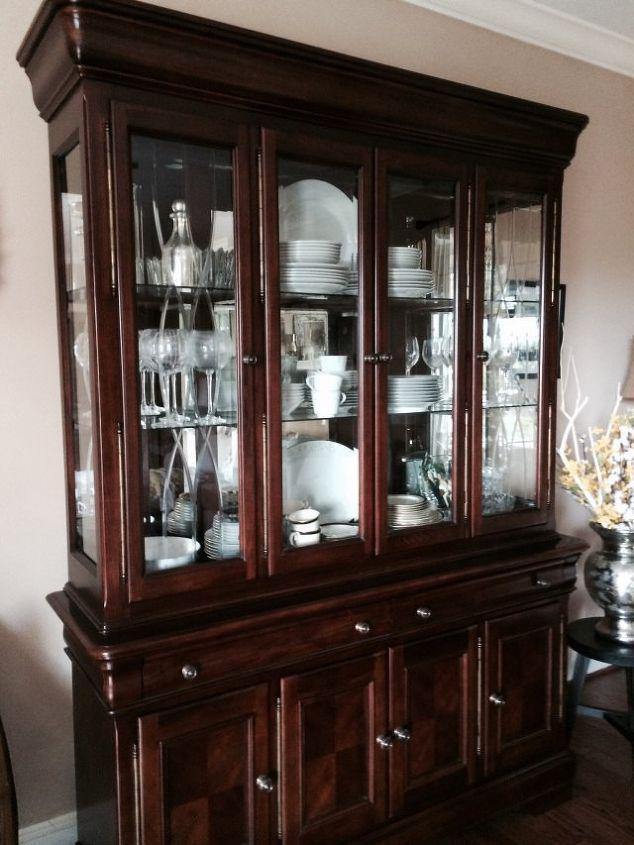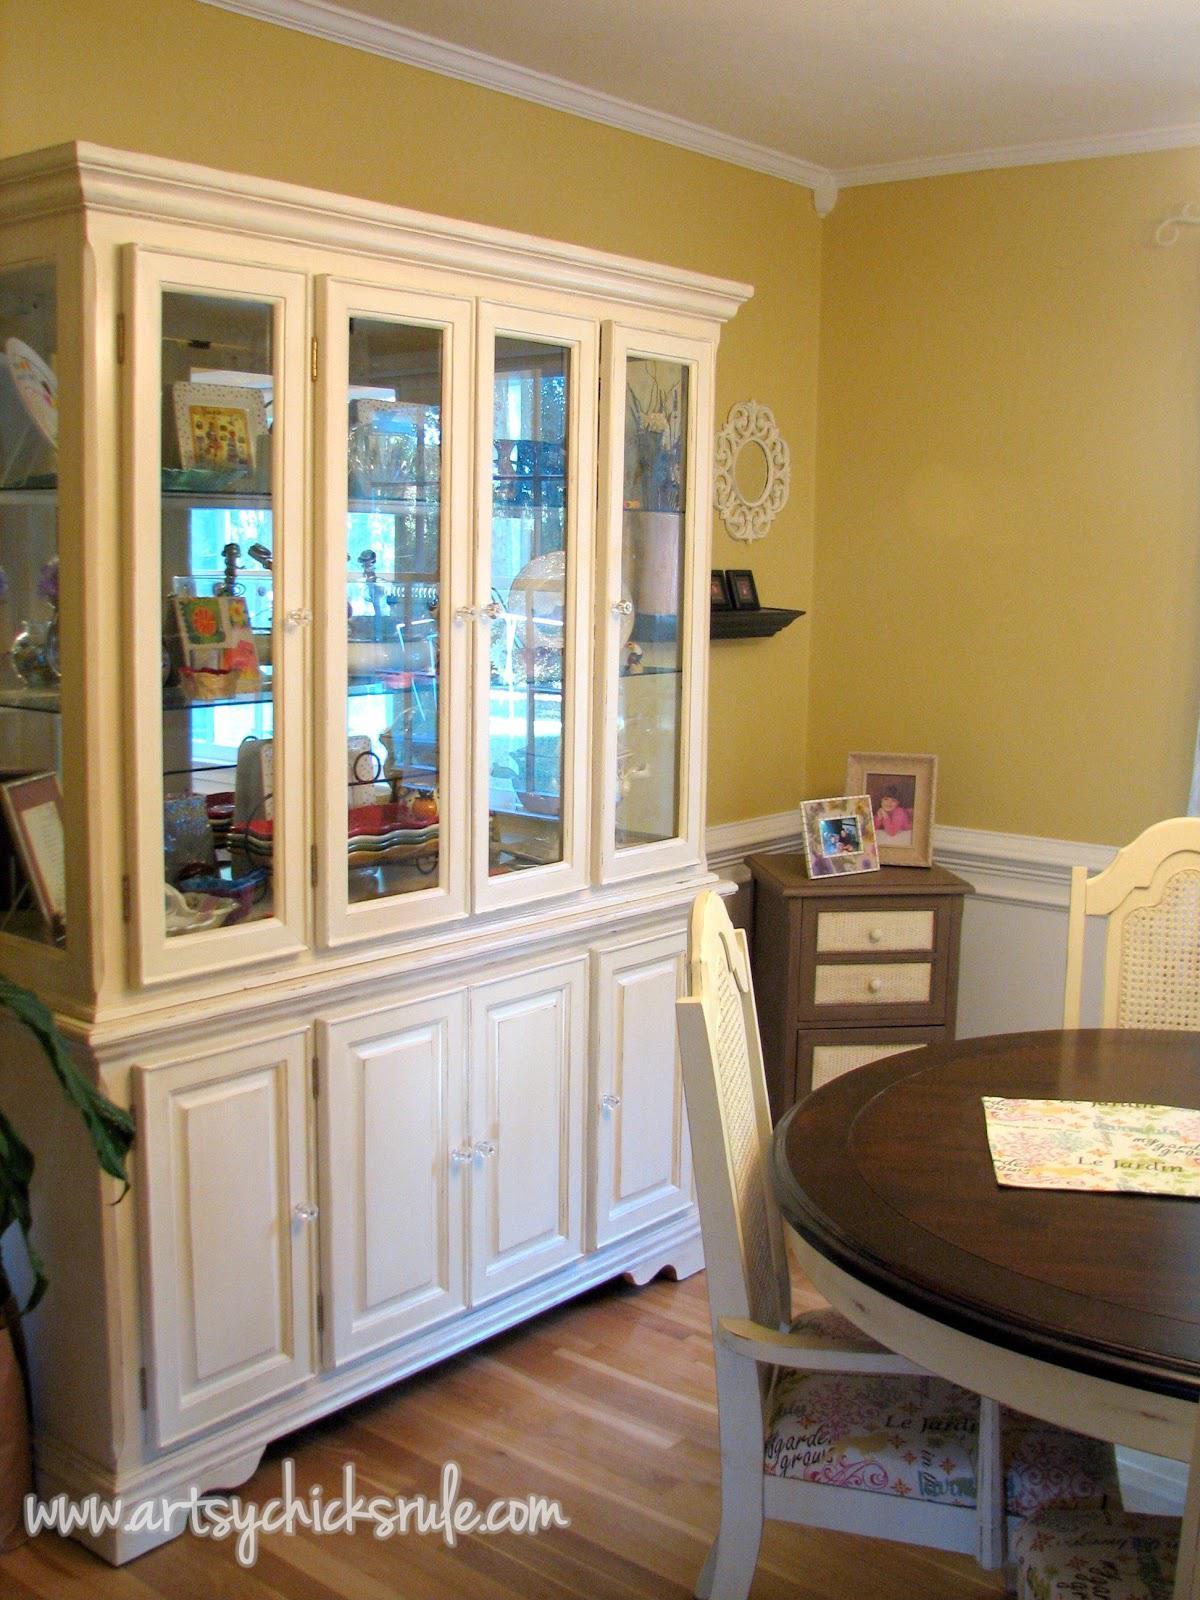The first image is the image on the left, the second image is the image on the right. Analyze the images presented: Is the assertion "The cabinet in the image on the left has an arch over the front center." valid? Answer yes or no. No. The first image is the image on the left, the second image is the image on the right. Given the left and right images, does the statement "There is at least one hutch that is painted dark gray." hold true? Answer yes or no. No. 